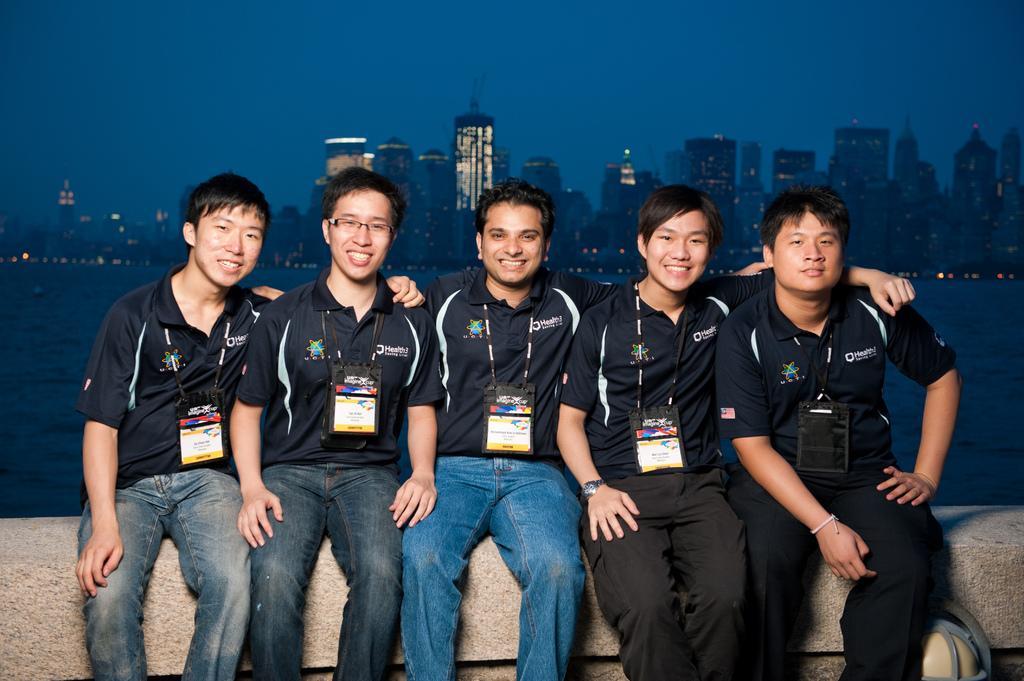Describe this image in one or two sentences. In the foreground we can see people sitting on a stone surface. In the middle there is a water body. In the background there are buildings and sky. 